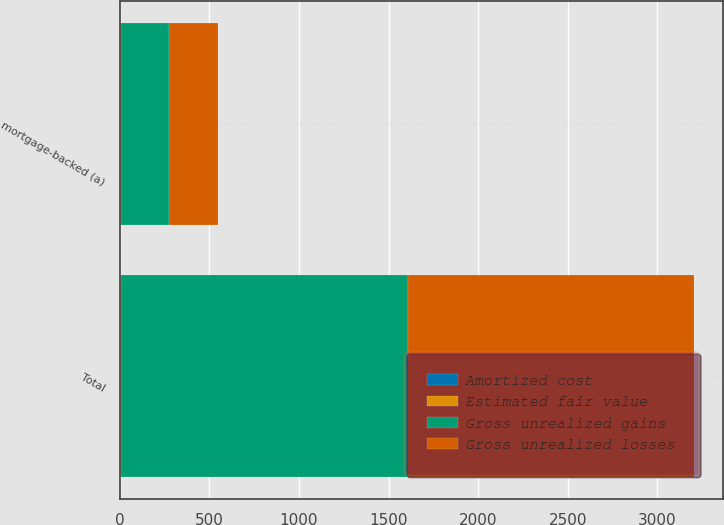Convert chart. <chart><loc_0><loc_0><loc_500><loc_500><stacked_bar_chart><ecel><fcel>mortgage-backed (a)<fcel>Total<nl><fcel>Gross unrealized losses<fcel>271<fcel>1598<nl><fcel>Amortized cost<fcel>3<fcel>4<nl><fcel>Estimated fair value<fcel>3<fcel>4<nl><fcel>Gross unrealized gains<fcel>271<fcel>1598<nl></chart> 